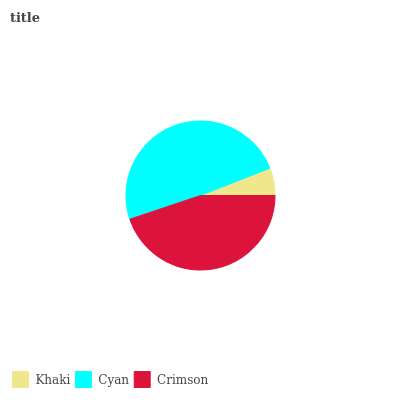Is Khaki the minimum?
Answer yes or no. Yes. Is Cyan the maximum?
Answer yes or no. Yes. Is Crimson the minimum?
Answer yes or no. No. Is Crimson the maximum?
Answer yes or no. No. Is Cyan greater than Crimson?
Answer yes or no. Yes. Is Crimson less than Cyan?
Answer yes or no. Yes. Is Crimson greater than Cyan?
Answer yes or no. No. Is Cyan less than Crimson?
Answer yes or no. No. Is Crimson the high median?
Answer yes or no. Yes. Is Crimson the low median?
Answer yes or no. Yes. Is Cyan the high median?
Answer yes or no. No. Is Cyan the low median?
Answer yes or no. No. 